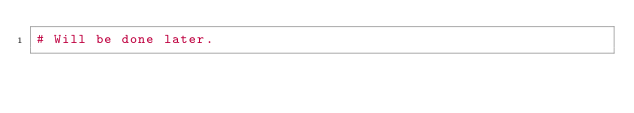Convert code to text. <code><loc_0><loc_0><loc_500><loc_500><_Python_># Will be done later.</code> 